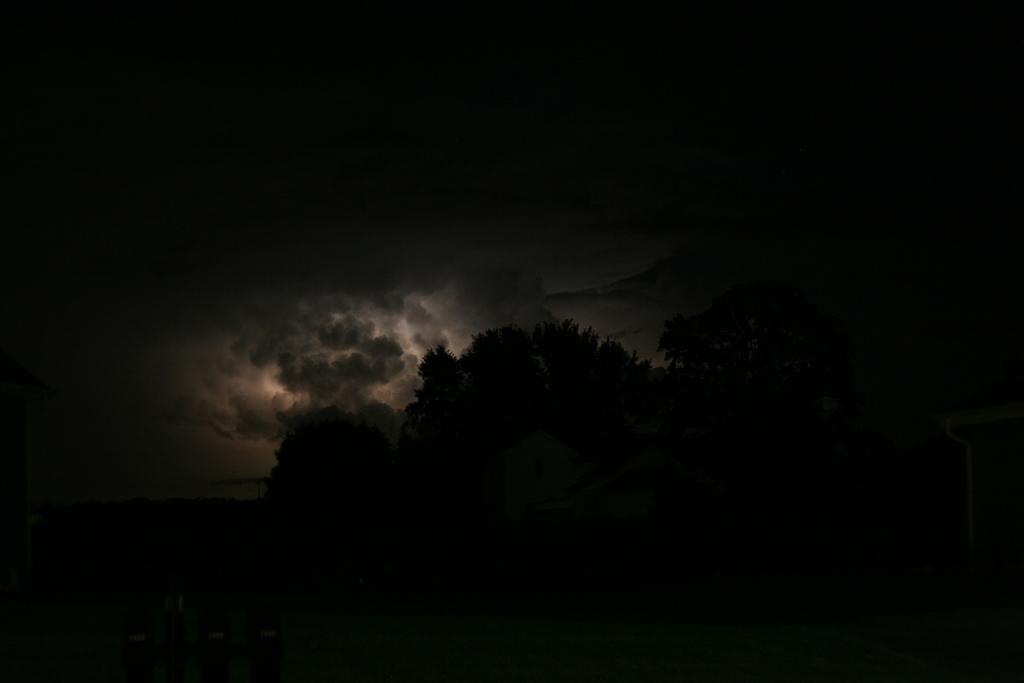Describe this image in one or two sentences. In this image, we can see dark view. In the middle of the picture, we can see trees and houses. In the background, there is the sky. 